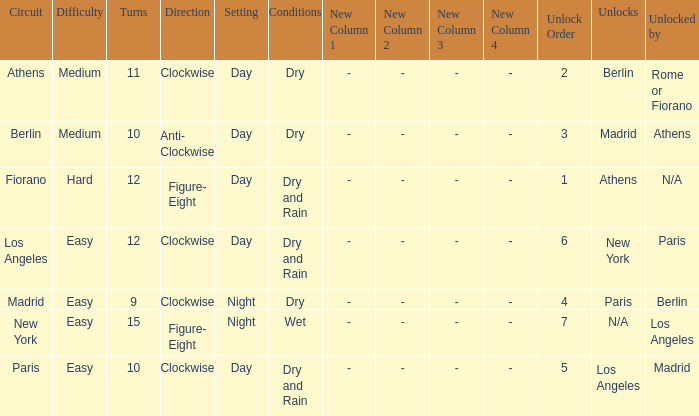What is the setting for the hard difficulty? Day. 